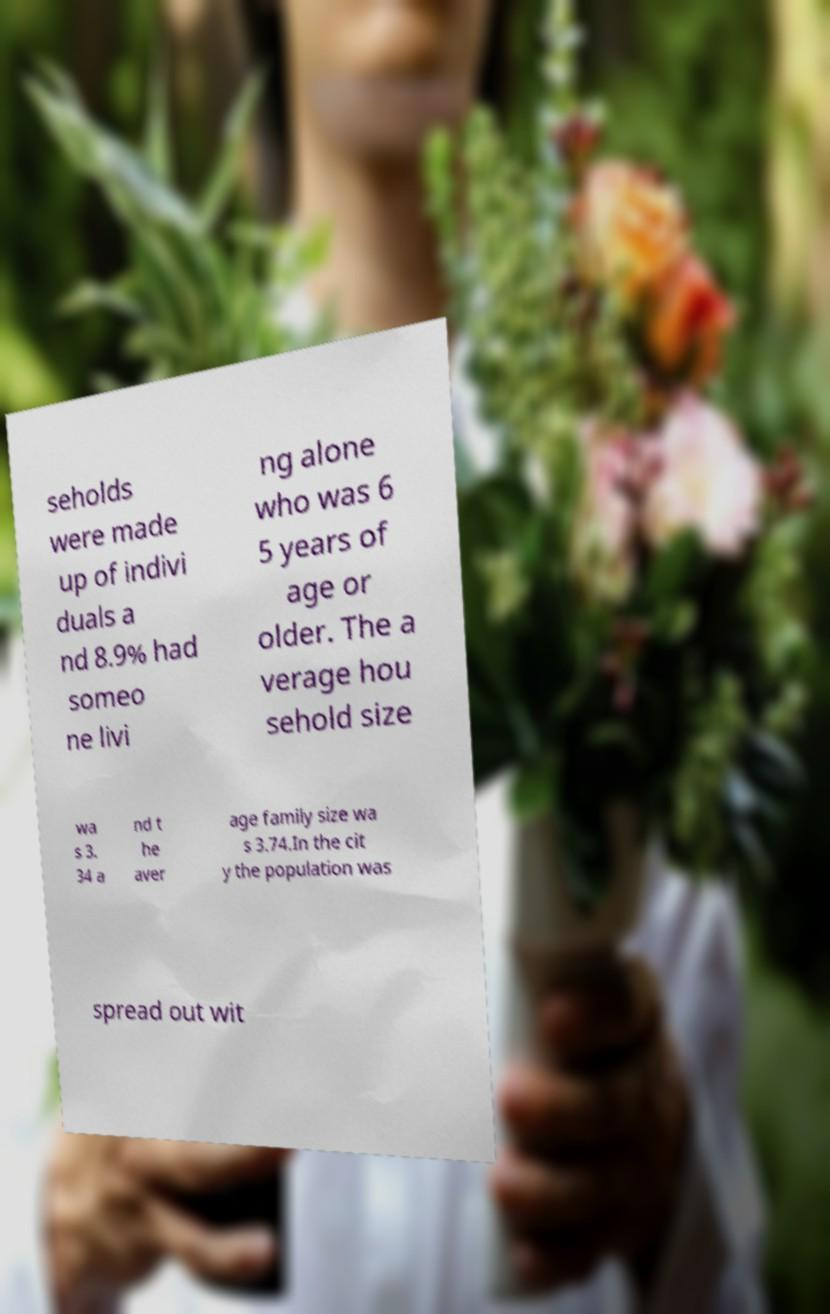There's text embedded in this image that I need extracted. Can you transcribe it verbatim? seholds were made up of indivi duals a nd 8.9% had someo ne livi ng alone who was 6 5 years of age or older. The a verage hou sehold size wa s 3. 34 a nd t he aver age family size wa s 3.74.In the cit y the population was spread out wit 